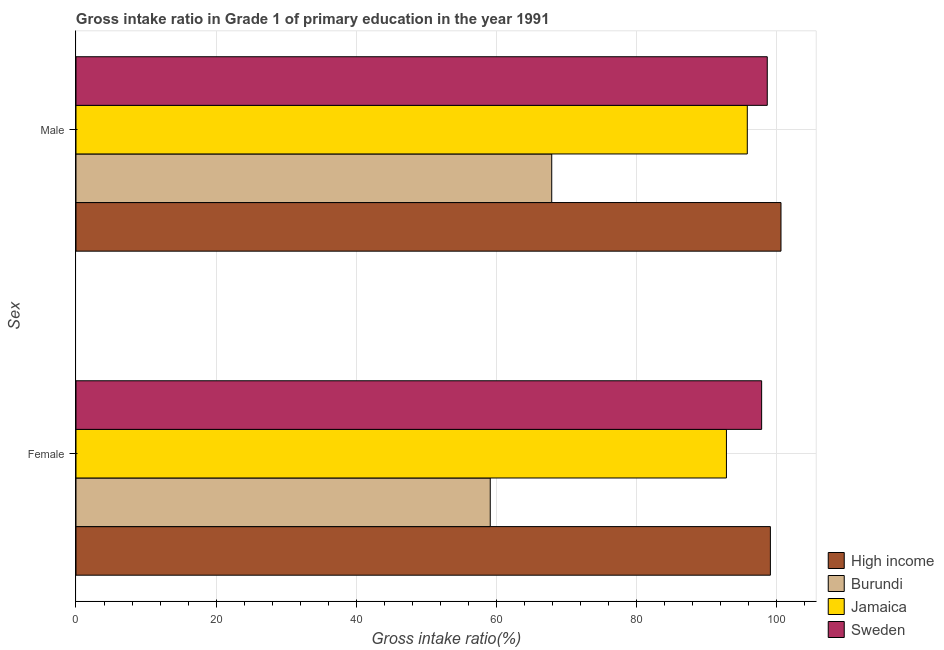How many different coloured bars are there?
Your response must be concise. 4. How many groups of bars are there?
Offer a very short reply. 2. Are the number of bars on each tick of the Y-axis equal?
Offer a terse response. Yes. How many bars are there on the 2nd tick from the top?
Offer a terse response. 4. How many bars are there on the 2nd tick from the bottom?
Provide a succinct answer. 4. What is the gross intake ratio(male) in High income?
Your response must be concise. 100.66. Across all countries, what is the maximum gross intake ratio(female)?
Make the answer very short. 99.15. Across all countries, what is the minimum gross intake ratio(male)?
Keep it short and to the point. 67.93. In which country was the gross intake ratio(male) maximum?
Your answer should be compact. High income. In which country was the gross intake ratio(female) minimum?
Your answer should be compact. Burundi. What is the total gross intake ratio(female) in the graph?
Your response must be concise. 349.07. What is the difference between the gross intake ratio(male) in Burundi and that in Jamaica?
Offer a terse response. -27.92. What is the difference between the gross intake ratio(female) in Jamaica and the gross intake ratio(male) in Sweden?
Your answer should be compact. -5.83. What is the average gross intake ratio(male) per country?
Your response must be concise. 90.79. What is the difference between the gross intake ratio(female) and gross intake ratio(male) in Sweden?
Make the answer very short. -0.8. In how many countries, is the gross intake ratio(male) greater than 100 %?
Your response must be concise. 1. What is the ratio of the gross intake ratio(female) in Sweden to that in Burundi?
Your answer should be compact. 1.66. What does the 4th bar from the top in Male represents?
Offer a terse response. High income. How many bars are there?
Provide a short and direct response. 8. What is the difference between two consecutive major ticks on the X-axis?
Your answer should be very brief. 20. Are the values on the major ticks of X-axis written in scientific E-notation?
Offer a very short reply. No. Does the graph contain any zero values?
Ensure brevity in your answer.  No. Where does the legend appear in the graph?
Ensure brevity in your answer.  Bottom right. How many legend labels are there?
Make the answer very short. 4. What is the title of the graph?
Offer a terse response. Gross intake ratio in Grade 1 of primary education in the year 1991. Does "Ireland" appear as one of the legend labels in the graph?
Your answer should be very brief. No. What is the label or title of the X-axis?
Provide a short and direct response. Gross intake ratio(%). What is the label or title of the Y-axis?
Your answer should be compact. Sex. What is the Gross intake ratio(%) of High income in Female?
Provide a succinct answer. 99.15. What is the Gross intake ratio(%) in Burundi in Female?
Give a very brief answer. 59.15. What is the Gross intake ratio(%) of Jamaica in Female?
Your response must be concise. 92.87. What is the Gross intake ratio(%) in Sweden in Female?
Offer a very short reply. 97.9. What is the Gross intake ratio(%) of High income in Male?
Provide a short and direct response. 100.66. What is the Gross intake ratio(%) of Burundi in Male?
Ensure brevity in your answer.  67.93. What is the Gross intake ratio(%) in Jamaica in Male?
Provide a succinct answer. 95.85. What is the Gross intake ratio(%) of Sweden in Male?
Give a very brief answer. 98.7. Across all Sex, what is the maximum Gross intake ratio(%) in High income?
Make the answer very short. 100.66. Across all Sex, what is the maximum Gross intake ratio(%) in Burundi?
Provide a succinct answer. 67.93. Across all Sex, what is the maximum Gross intake ratio(%) of Jamaica?
Your answer should be compact. 95.85. Across all Sex, what is the maximum Gross intake ratio(%) in Sweden?
Offer a terse response. 98.7. Across all Sex, what is the minimum Gross intake ratio(%) in High income?
Offer a very short reply. 99.15. Across all Sex, what is the minimum Gross intake ratio(%) of Burundi?
Your answer should be very brief. 59.15. Across all Sex, what is the minimum Gross intake ratio(%) in Jamaica?
Ensure brevity in your answer.  92.87. Across all Sex, what is the minimum Gross intake ratio(%) of Sweden?
Provide a short and direct response. 97.9. What is the total Gross intake ratio(%) in High income in the graph?
Offer a very short reply. 199.81. What is the total Gross intake ratio(%) of Burundi in the graph?
Make the answer very short. 127.08. What is the total Gross intake ratio(%) of Jamaica in the graph?
Keep it short and to the point. 188.72. What is the total Gross intake ratio(%) in Sweden in the graph?
Make the answer very short. 196.6. What is the difference between the Gross intake ratio(%) of High income in Female and that in Male?
Keep it short and to the point. -1.51. What is the difference between the Gross intake ratio(%) of Burundi in Female and that in Male?
Offer a terse response. -8.78. What is the difference between the Gross intake ratio(%) of Jamaica in Female and that in Male?
Provide a short and direct response. -2.98. What is the difference between the Gross intake ratio(%) of Sweden in Female and that in Male?
Make the answer very short. -0.8. What is the difference between the Gross intake ratio(%) in High income in Female and the Gross intake ratio(%) in Burundi in Male?
Keep it short and to the point. 31.22. What is the difference between the Gross intake ratio(%) in High income in Female and the Gross intake ratio(%) in Jamaica in Male?
Your response must be concise. 3.3. What is the difference between the Gross intake ratio(%) in High income in Female and the Gross intake ratio(%) in Sweden in Male?
Provide a succinct answer. 0.45. What is the difference between the Gross intake ratio(%) of Burundi in Female and the Gross intake ratio(%) of Jamaica in Male?
Keep it short and to the point. -36.7. What is the difference between the Gross intake ratio(%) in Burundi in Female and the Gross intake ratio(%) in Sweden in Male?
Keep it short and to the point. -39.55. What is the difference between the Gross intake ratio(%) of Jamaica in Female and the Gross intake ratio(%) of Sweden in Male?
Your answer should be compact. -5.83. What is the average Gross intake ratio(%) in High income per Sex?
Give a very brief answer. 99.9. What is the average Gross intake ratio(%) of Burundi per Sex?
Your answer should be very brief. 63.54. What is the average Gross intake ratio(%) in Jamaica per Sex?
Ensure brevity in your answer.  94.36. What is the average Gross intake ratio(%) of Sweden per Sex?
Your answer should be compact. 98.3. What is the difference between the Gross intake ratio(%) of High income and Gross intake ratio(%) of Burundi in Female?
Your answer should be very brief. 40. What is the difference between the Gross intake ratio(%) of High income and Gross intake ratio(%) of Jamaica in Female?
Offer a terse response. 6.28. What is the difference between the Gross intake ratio(%) of High income and Gross intake ratio(%) of Sweden in Female?
Give a very brief answer. 1.25. What is the difference between the Gross intake ratio(%) of Burundi and Gross intake ratio(%) of Jamaica in Female?
Your answer should be very brief. -33.72. What is the difference between the Gross intake ratio(%) of Burundi and Gross intake ratio(%) of Sweden in Female?
Ensure brevity in your answer.  -38.75. What is the difference between the Gross intake ratio(%) in Jamaica and Gross intake ratio(%) in Sweden in Female?
Your response must be concise. -5.03. What is the difference between the Gross intake ratio(%) of High income and Gross intake ratio(%) of Burundi in Male?
Make the answer very short. 32.73. What is the difference between the Gross intake ratio(%) in High income and Gross intake ratio(%) in Jamaica in Male?
Offer a very short reply. 4.81. What is the difference between the Gross intake ratio(%) in High income and Gross intake ratio(%) in Sweden in Male?
Keep it short and to the point. 1.96. What is the difference between the Gross intake ratio(%) in Burundi and Gross intake ratio(%) in Jamaica in Male?
Keep it short and to the point. -27.92. What is the difference between the Gross intake ratio(%) in Burundi and Gross intake ratio(%) in Sweden in Male?
Make the answer very short. -30.77. What is the difference between the Gross intake ratio(%) of Jamaica and Gross intake ratio(%) of Sweden in Male?
Ensure brevity in your answer.  -2.85. What is the ratio of the Gross intake ratio(%) of Burundi in Female to that in Male?
Keep it short and to the point. 0.87. What is the ratio of the Gross intake ratio(%) of Jamaica in Female to that in Male?
Keep it short and to the point. 0.97. What is the ratio of the Gross intake ratio(%) in Sweden in Female to that in Male?
Offer a terse response. 0.99. What is the difference between the highest and the second highest Gross intake ratio(%) in High income?
Provide a succinct answer. 1.51. What is the difference between the highest and the second highest Gross intake ratio(%) of Burundi?
Give a very brief answer. 8.78. What is the difference between the highest and the second highest Gross intake ratio(%) in Jamaica?
Offer a very short reply. 2.98. What is the difference between the highest and the second highest Gross intake ratio(%) in Sweden?
Your answer should be very brief. 0.8. What is the difference between the highest and the lowest Gross intake ratio(%) of High income?
Give a very brief answer. 1.51. What is the difference between the highest and the lowest Gross intake ratio(%) of Burundi?
Provide a short and direct response. 8.78. What is the difference between the highest and the lowest Gross intake ratio(%) of Jamaica?
Your response must be concise. 2.98. What is the difference between the highest and the lowest Gross intake ratio(%) in Sweden?
Your answer should be compact. 0.8. 